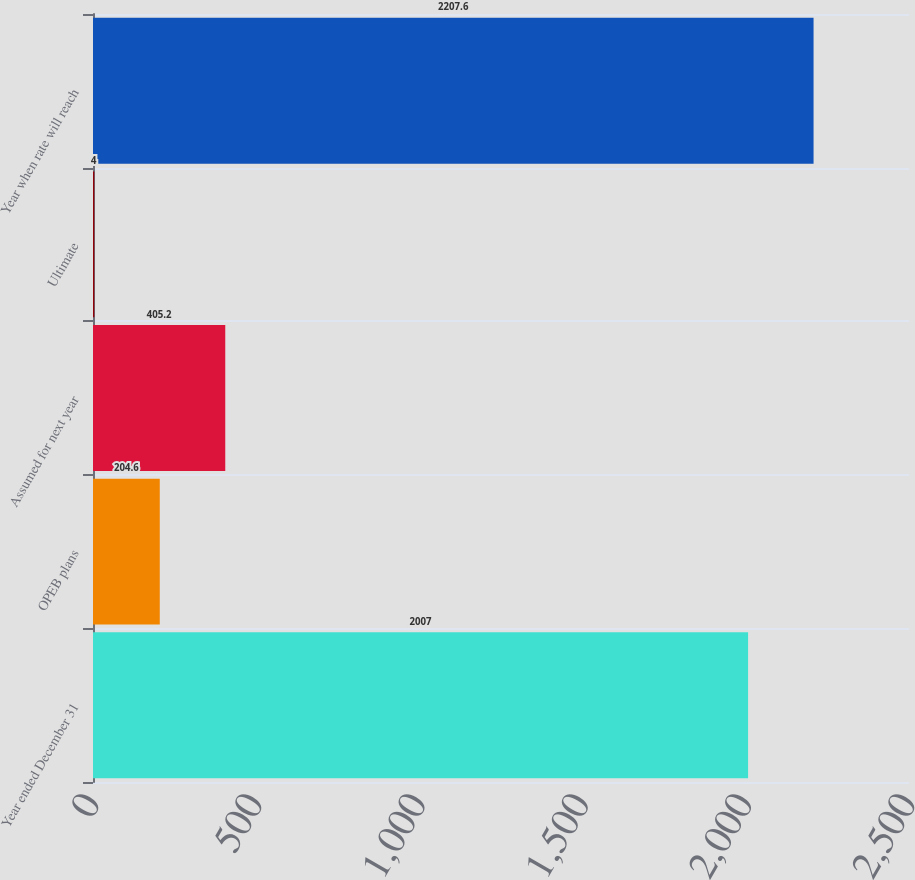<chart> <loc_0><loc_0><loc_500><loc_500><bar_chart><fcel>Year ended December 31<fcel>OPEB plans<fcel>Assumed for next year<fcel>Ultimate<fcel>Year when rate will reach<nl><fcel>2007<fcel>204.6<fcel>405.2<fcel>4<fcel>2207.6<nl></chart> 